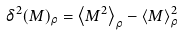Convert formula to latex. <formula><loc_0><loc_0><loc_500><loc_500>\delta ^ { 2 } ( M ) _ { \rho } = \left \langle M ^ { 2 } \right \rangle _ { \rho } - \left \langle M \right \rangle _ { \rho } ^ { 2 }</formula> 